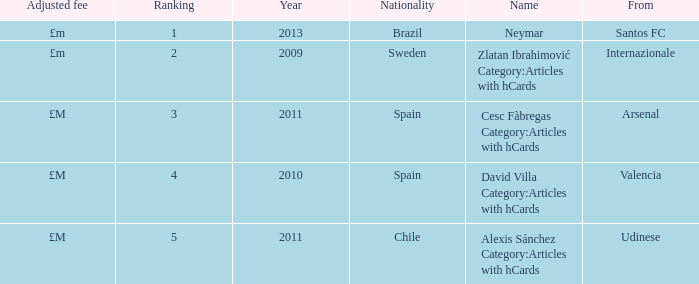What is the most recent year a player was from Valencia? 2010.0. 